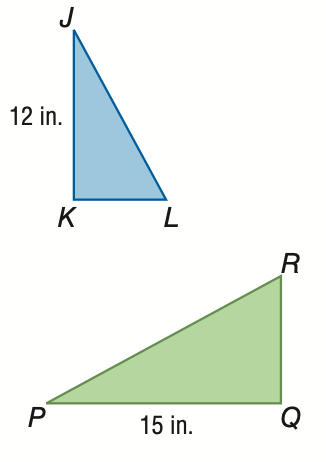Question: If \triangle J K L \sim \triangle P Q R and the area of \triangle J K L is 30 square inches, find the area of \triangle P Q R.
Choices:
A. 19.2
B. 24.0
C. 37.5
D. 46.9
Answer with the letter. Answer: D 